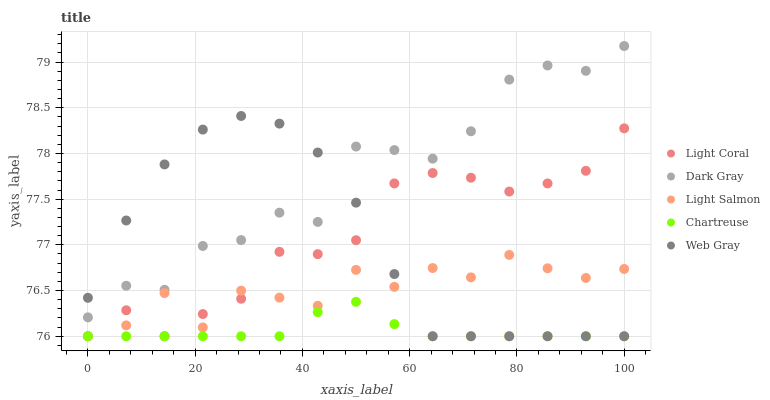Does Chartreuse have the minimum area under the curve?
Answer yes or no. Yes. Does Dark Gray have the maximum area under the curve?
Answer yes or no. Yes. Does Light Salmon have the minimum area under the curve?
Answer yes or no. No. Does Light Salmon have the maximum area under the curve?
Answer yes or no. No. Is Chartreuse the smoothest?
Answer yes or no. Yes. Is Dark Gray the roughest?
Answer yes or no. Yes. Is Light Salmon the smoothest?
Answer yes or no. No. Is Light Salmon the roughest?
Answer yes or no. No. Does Light Coral have the lowest value?
Answer yes or no. Yes. Does Dark Gray have the lowest value?
Answer yes or no. No. Does Dark Gray have the highest value?
Answer yes or no. Yes. Does Light Salmon have the highest value?
Answer yes or no. No. Is Chartreuse less than Dark Gray?
Answer yes or no. Yes. Is Dark Gray greater than Light Salmon?
Answer yes or no. Yes. Does Web Gray intersect Chartreuse?
Answer yes or no. Yes. Is Web Gray less than Chartreuse?
Answer yes or no. No. Is Web Gray greater than Chartreuse?
Answer yes or no. No. Does Chartreuse intersect Dark Gray?
Answer yes or no. No. 